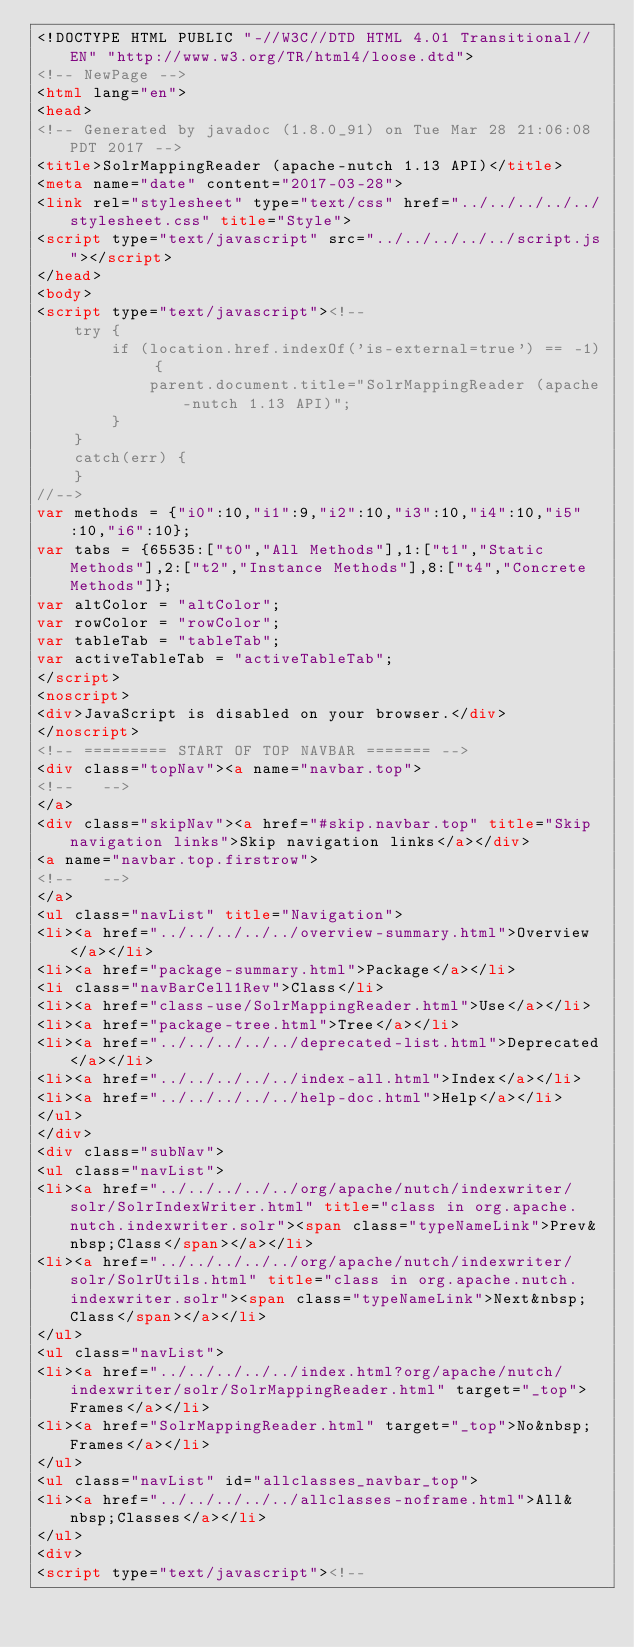Convert code to text. <code><loc_0><loc_0><loc_500><loc_500><_HTML_><!DOCTYPE HTML PUBLIC "-//W3C//DTD HTML 4.01 Transitional//EN" "http://www.w3.org/TR/html4/loose.dtd">
<!-- NewPage -->
<html lang="en">
<head>
<!-- Generated by javadoc (1.8.0_91) on Tue Mar 28 21:06:08 PDT 2017 -->
<title>SolrMappingReader (apache-nutch 1.13 API)</title>
<meta name="date" content="2017-03-28">
<link rel="stylesheet" type="text/css" href="../../../../../stylesheet.css" title="Style">
<script type="text/javascript" src="../../../../../script.js"></script>
</head>
<body>
<script type="text/javascript"><!--
    try {
        if (location.href.indexOf('is-external=true') == -1) {
            parent.document.title="SolrMappingReader (apache-nutch 1.13 API)";
        }
    }
    catch(err) {
    }
//-->
var methods = {"i0":10,"i1":9,"i2":10,"i3":10,"i4":10,"i5":10,"i6":10};
var tabs = {65535:["t0","All Methods"],1:["t1","Static Methods"],2:["t2","Instance Methods"],8:["t4","Concrete Methods"]};
var altColor = "altColor";
var rowColor = "rowColor";
var tableTab = "tableTab";
var activeTableTab = "activeTableTab";
</script>
<noscript>
<div>JavaScript is disabled on your browser.</div>
</noscript>
<!-- ========= START OF TOP NAVBAR ======= -->
<div class="topNav"><a name="navbar.top">
<!--   -->
</a>
<div class="skipNav"><a href="#skip.navbar.top" title="Skip navigation links">Skip navigation links</a></div>
<a name="navbar.top.firstrow">
<!--   -->
</a>
<ul class="navList" title="Navigation">
<li><a href="../../../../../overview-summary.html">Overview</a></li>
<li><a href="package-summary.html">Package</a></li>
<li class="navBarCell1Rev">Class</li>
<li><a href="class-use/SolrMappingReader.html">Use</a></li>
<li><a href="package-tree.html">Tree</a></li>
<li><a href="../../../../../deprecated-list.html">Deprecated</a></li>
<li><a href="../../../../../index-all.html">Index</a></li>
<li><a href="../../../../../help-doc.html">Help</a></li>
</ul>
</div>
<div class="subNav">
<ul class="navList">
<li><a href="../../../../../org/apache/nutch/indexwriter/solr/SolrIndexWriter.html" title="class in org.apache.nutch.indexwriter.solr"><span class="typeNameLink">Prev&nbsp;Class</span></a></li>
<li><a href="../../../../../org/apache/nutch/indexwriter/solr/SolrUtils.html" title="class in org.apache.nutch.indexwriter.solr"><span class="typeNameLink">Next&nbsp;Class</span></a></li>
</ul>
<ul class="navList">
<li><a href="../../../../../index.html?org/apache/nutch/indexwriter/solr/SolrMappingReader.html" target="_top">Frames</a></li>
<li><a href="SolrMappingReader.html" target="_top">No&nbsp;Frames</a></li>
</ul>
<ul class="navList" id="allclasses_navbar_top">
<li><a href="../../../../../allclasses-noframe.html">All&nbsp;Classes</a></li>
</ul>
<div>
<script type="text/javascript"><!--</code> 